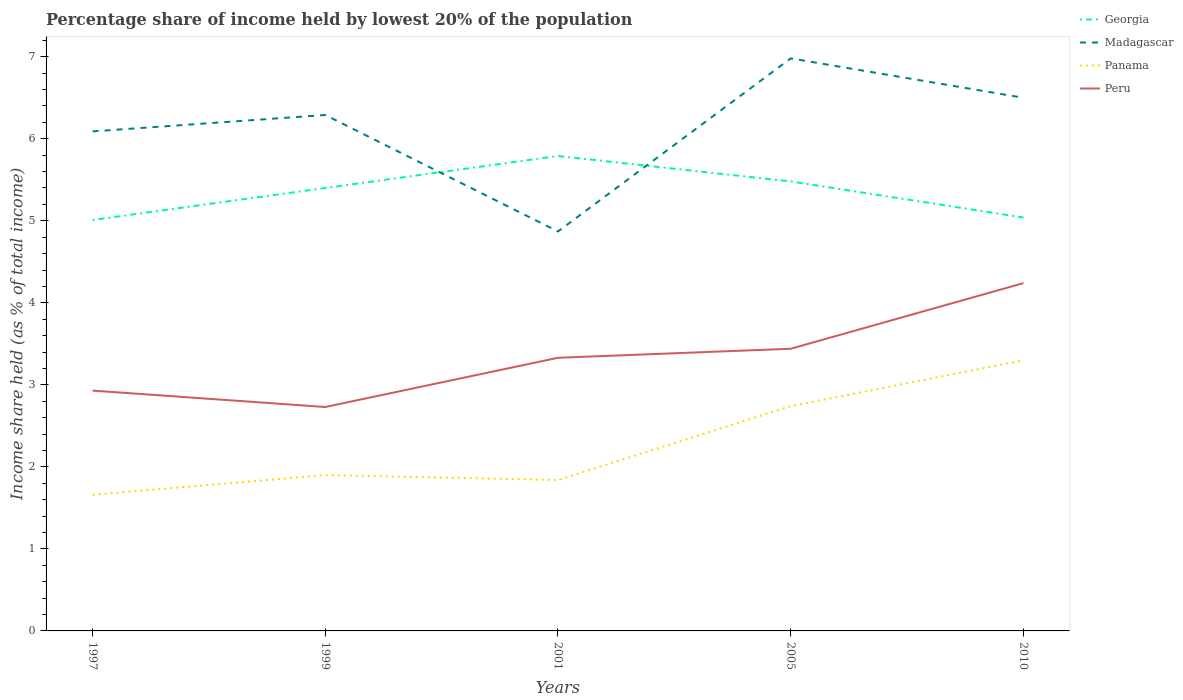Across all years, what is the maximum percentage share of income held by lowest 20% of the population in Panama?
Your response must be concise. 1.66. In which year was the percentage share of income held by lowest 20% of the population in Madagascar maximum?
Your response must be concise. 2001. What is the total percentage share of income held by lowest 20% of the population in Madagascar in the graph?
Provide a succinct answer. -0.2. What is the difference between the highest and the second highest percentage share of income held by lowest 20% of the population in Madagascar?
Ensure brevity in your answer.  2.11. What is the difference between the highest and the lowest percentage share of income held by lowest 20% of the population in Madagascar?
Offer a terse response. 3. How many lines are there?
Your answer should be compact. 4. What is the difference between two consecutive major ticks on the Y-axis?
Your answer should be compact. 1. Are the values on the major ticks of Y-axis written in scientific E-notation?
Your answer should be compact. No. Does the graph contain any zero values?
Ensure brevity in your answer.  No. Does the graph contain grids?
Your answer should be compact. No. How are the legend labels stacked?
Keep it short and to the point. Vertical. What is the title of the graph?
Offer a very short reply. Percentage share of income held by lowest 20% of the population. Does "Pakistan" appear as one of the legend labels in the graph?
Your answer should be compact. No. What is the label or title of the X-axis?
Make the answer very short. Years. What is the label or title of the Y-axis?
Offer a terse response. Income share held (as % of total income). What is the Income share held (as % of total income) in Georgia in 1997?
Make the answer very short. 5.01. What is the Income share held (as % of total income) in Madagascar in 1997?
Offer a terse response. 6.09. What is the Income share held (as % of total income) of Panama in 1997?
Give a very brief answer. 1.66. What is the Income share held (as % of total income) in Peru in 1997?
Your answer should be compact. 2.93. What is the Income share held (as % of total income) in Georgia in 1999?
Ensure brevity in your answer.  5.4. What is the Income share held (as % of total income) of Madagascar in 1999?
Give a very brief answer. 6.29. What is the Income share held (as % of total income) of Peru in 1999?
Keep it short and to the point. 2.73. What is the Income share held (as % of total income) in Georgia in 2001?
Keep it short and to the point. 5.79. What is the Income share held (as % of total income) of Madagascar in 2001?
Provide a short and direct response. 4.87. What is the Income share held (as % of total income) in Panama in 2001?
Your answer should be compact. 1.84. What is the Income share held (as % of total income) of Peru in 2001?
Give a very brief answer. 3.33. What is the Income share held (as % of total income) of Georgia in 2005?
Keep it short and to the point. 5.48. What is the Income share held (as % of total income) in Madagascar in 2005?
Your answer should be very brief. 6.98. What is the Income share held (as % of total income) in Panama in 2005?
Ensure brevity in your answer.  2.74. What is the Income share held (as % of total income) of Peru in 2005?
Give a very brief answer. 3.44. What is the Income share held (as % of total income) in Georgia in 2010?
Offer a very short reply. 5.04. What is the Income share held (as % of total income) of Madagascar in 2010?
Make the answer very short. 6.5. What is the Income share held (as % of total income) in Panama in 2010?
Offer a very short reply. 3.3. What is the Income share held (as % of total income) of Peru in 2010?
Offer a very short reply. 4.24. Across all years, what is the maximum Income share held (as % of total income) of Georgia?
Keep it short and to the point. 5.79. Across all years, what is the maximum Income share held (as % of total income) of Madagascar?
Offer a very short reply. 6.98. Across all years, what is the maximum Income share held (as % of total income) of Panama?
Keep it short and to the point. 3.3. Across all years, what is the maximum Income share held (as % of total income) in Peru?
Provide a succinct answer. 4.24. Across all years, what is the minimum Income share held (as % of total income) of Georgia?
Give a very brief answer. 5.01. Across all years, what is the minimum Income share held (as % of total income) in Madagascar?
Provide a succinct answer. 4.87. Across all years, what is the minimum Income share held (as % of total income) of Panama?
Provide a succinct answer. 1.66. Across all years, what is the minimum Income share held (as % of total income) of Peru?
Provide a short and direct response. 2.73. What is the total Income share held (as % of total income) in Georgia in the graph?
Offer a terse response. 26.72. What is the total Income share held (as % of total income) of Madagascar in the graph?
Ensure brevity in your answer.  30.73. What is the total Income share held (as % of total income) in Panama in the graph?
Keep it short and to the point. 11.44. What is the total Income share held (as % of total income) in Peru in the graph?
Ensure brevity in your answer.  16.67. What is the difference between the Income share held (as % of total income) in Georgia in 1997 and that in 1999?
Offer a terse response. -0.39. What is the difference between the Income share held (as % of total income) of Madagascar in 1997 and that in 1999?
Your response must be concise. -0.2. What is the difference between the Income share held (as % of total income) in Panama in 1997 and that in 1999?
Keep it short and to the point. -0.24. What is the difference between the Income share held (as % of total income) of Peru in 1997 and that in 1999?
Provide a short and direct response. 0.2. What is the difference between the Income share held (as % of total income) in Georgia in 1997 and that in 2001?
Keep it short and to the point. -0.78. What is the difference between the Income share held (as % of total income) in Madagascar in 1997 and that in 2001?
Offer a very short reply. 1.22. What is the difference between the Income share held (as % of total income) in Panama in 1997 and that in 2001?
Offer a very short reply. -0.18. What is the difference between the Income share held (as % of total income) of Peru in 1997 and that in 2001?
Offer a terse response. -0.4. What is the difference between the Income share held (as % of total income) of Georgia in 1997 and that in 2005?
Give a very brief answer. -0.47. What is the difference between the Income share held (as % of total income) of Madagascar in 1997 and that in 2005?
Offer a terse response. -0.89. What is the difference between the Income share held (as % of total income) in Panama in 1997 and that in 2005?
Provide a short and direct response. -1.08. What is the difference between the Income share held (as % of total income) in Peru in 1997 and that in 2005?
Provide a succinct answer. -0.51. What is the difference between the Income share held (as % of total income) in Georgia in 1997 and that in 2010?
Provide a succinct answer. -0.03. What is the difference between the Income share held (as % of total income) of Madagascar in 1997 and that in 2010?
Offer a terse response. -0.41. What is the difference between the Income share held (as % of total income) of Panama in 1997 and that in 2010?
Your answer should be very brief. -1.64. What is the difference between the Income share held (as % of total income) in Peru in 1997 and that in 2010?
Ensure brevity in your answer.  -1.31. What is the difference between the Income share held (as % of total income) in Georgia in 1999 and that in 2001?
Provide a short and direct response. -0.39. What is the difference between the Income share held (as % of total income) of Madagascar in 1999 and that in 2001?
Make the answer very short. 1.42. What is the difference between the Income share held (as % of total income) of Panama in 1999 and that in 2001?
Your answer should be very brief. 0.06. What is the difference between the Income share held (as % of total income) in Peru in 1999 and that in 2001?
Offer a terse response. -0.6. What is the difference between the Income share held (as % of total income) in Georgia in 1999 and that in 2005?
Ensure brevity in your answer.  -0.08. What is the difference between the Income share held (as % of total income) in Madagascar in 1999 and that in 2005?
Your answer should be very brief. -0.69. What is the difference between the Income share held (as % of total income) of Panama in 1999 and that in 2005?
Keep it short and to the point. -0.84. What is the difference between the Income share held (as % of total income) in Peru in 1999 and that in 2005?
Ensure brevity in your answer.  -0.71. What is the difference between the Income share held (as % of total income) of Georgia in 1999 and that in 2010?
Provide a succinct answer. 0.36. What is the difference between the Income share held (as % of total income) in Madagascar in 1999 and that in 2010?
Ensure brevity in your answer.  -0.21. What is the difference between the Income share held (as % of total income) in Panama in 1999 and that in 2010?
Offer a terse response. -1.4. What is the difference between the Income share held (as % of total income) of Peru in 1999 and that in 2010?
Provide a short and direct response. -1.51. What is the difference between the Income share held (as % of total income) of Georgia in 2001 and that in 2005?
Offer a terse response. 0.31. What is the difference between the Income share held (as % of total income) in Madagascar in 2001 and that in 2005?
Provide a succinct answer. -2.11. What is the difference between the Income share held (as % of total income) of Panama in 2001 and that in 2005?
Offer a very short reply. -0.9. What is the difference between the Income share held (as % of total income) in Peru in 2001 and that in 2005?
Offer a terse response. -0.11. What is the difference between the Income share held (as % of total income) of Georgia in 2001 and that in 2010?
Keep it short and to the point. 0.75. What is the difference between the Income share held (as % of total income) in Madagascar in 2001 and that in 2010?
Keep it short and to the point. -1.63. What is the difference between the Income share held (as % of total income) in Panama in 2001 and that in 2010?
Provide a short and direct response. -1.46. What is the difference between the Income share held (as % of total income) of Peru in 2001 and that in 2010?
Provide a short and direct response. -0.91. What is the difference between the Income share held (as % of total income) of Georgia in 2005 and that in 2010?
Offer a very short reply. 0.44. What is the difference between the Income share held (as % of total income) of Madagascar in 2005 and that in 2010?
Make the answer very short. 0.48. What is the difference between the Income share held (as % of total income) of Panama in 2005 and that in 2010?
Keep it short and to the point. -0.56. What is the difference between the Income share held (as % of total income) in Georgia in 1997 and the Income share held (as % of total income) in Madagascar in 1999?
Make the answer very short. -1.28. What is the difference between the Income share held (as % of total income) in Georgia in 1997 and the Income share held (as % of total income) in Panama in 1999?
Make the answer very short. 3.11. What is the difference between the Income share held (as % of total income) of Georgia in 1997 and the Income share held (as % of total income) of Peru in 1999?
Your answer should be very brief. 2.28. What is the difference between the Income share held (as % of total income) in Madagascar in 1997 and the Income share held (as % of total income) in Panama in 1999?
Keep it short and to the point. 4.19. What is the difference between the Income share held (as % of total income) of Madagascar in 1997 and the Income share held (as % of total income) of Peru in 1999?
Give a very brief answer. 3.36. What is the difference between the Income share held (as % of total income) of Panama in 1997 and the Income share held (as % of total income) of Peru in 1999?
Your answer should be very brief. -1.07. What is the difference between the Income share held (as % of total income) of Georgia in 1997 and the Income share held (as % of total income) of Madagascar in 2001?
Keep it short and to the point. 0.14. What is the difference between the Income share held (as % of total income) of Georgia in 1997 and the Income share held (as % of total income) of Panama in 2001?
Provide a succinct answer. 3.17. What is the difference between the Income share held (as % of total income) of Georgia in 1997 and the Income share held (as % of total income) of Peru in 2001?
Your answer should be compact. 1.68. What is the difference between the Income share held (as % of total income) of Madagascar in 1997 and the Income share held (as % of total income) of Panama in 2001?
Ensure brevity in your answer.  4.25. What is the difference between the Income share held (as % of total income) of Madagascar in 1997 and the Income share held (as % of total income) of Peru in 2001?
Your response must be concise. 2.76. What is the difference between the Income share held (as % of total income) in Panama in 1997 and the Income share held (as % of total income) in Peru in 2001?
Give a very brief answer. -1.67. What is the difference between the Income share held (as % of total income) in Georgia in 1997 and the Income share held (as % of total income) in Madagascar in 2005?
Keep it short and to the point. -1.97. What is the difference between the Income share held (as % of total income) in Georgia in 1997 and the Income share held (as % of total income) in Panama in 2005?
Your answer should be very brief. 2.27. What is the difference between the Income share held (as % of total income) of Georgia in 1997 and the Income share held (as % of total income) of Peru in 2005?
Your answer should be very brief. 1.57. What is the difference between the Income share held (as % of total income) in Madagascar in 1997 and the Income share held (as % of total income) in Panama in 2005?
Your response must be concise. 3.35. What is the difference between the Income share held (as % of total income) of Madagascar in 1997 and the Income share held (as % of total income) of Peru in 2005?
Your response must be concise. 2.65. What is the difference between the Income share held (as % of total income) in Panama in 1997 and the Income share held (as % of total income) in Peru in 2005?
Give a very brief answer. -1.78. What is the difference between the Income share held (as % of total income) of Georgia in 1997 and the Income share held (as % of total income) of Madagascar in 2010?
Your answer should be compact. -1.49. What is the difference between the Income share held (as % of total income) in Georgia in 1997 and the Income share held (as % of total income) in Panama in 2010?
Offer a very short reply. 1.71. What is the difference between the Income share held (as % of total income) of Georgia in 1997 and the Income share held (as % of total income) of Peru in 2010?
Ensure brevity in your answer.  0.77. What is the difference between the Income share held (as % of total income) in Madagascar in 1997 and the Income share held (as % of total income) in Panama in 2010?
Offer a terse response. 2.79. What is the difference between the Income share held (as % of total income) of Madagascar in 1997 and the Income share held (as % of total income) of Peru in 2010?
Offer a terse response. 1.85. What is the difference between the Income share held (as % of total income) in Panama in 1997 and the Income share held (as % of total income) in Peru in 2010?
Your answer should be compact. -2.58. What is the difference between the Income share held (as % of total income) of Georgia in 1999 and the Income share held (as % of total income) of Madagascar in 2001?
Provide a succinct answer. 0.53. What is the difference between the Income share held (as % of total income) of Georgia in 1999 and the Income share held (as % of total income) of Panama in 2001?
Ensure brevity in your answer.  3.56. What is the difference between the Income share held (as % of total income) of Georgia in 1999 and the Income share held (as % of total income) of Peru in 2001?
Provide a succinct answer. 2.07. What is the difference between the Income share held (as % of total income) of Madagascar in 1999 and the Income share held (as % of total income) of Panama in 2001?
Give a very brief answer. 4.45. What is the difference between the Income share held (as % of total income) of Madagascar in 1999 and the Income share held (as % of total income) of Peru in 2001?
Your answer should be very brief. 2.96. What is the difference between the Income share held (as % of total income) in Panama in 1999 and the Income share held (as % of total income) in Peru in 2001?
Ensure brevity in your answer.  -1.43. What is the difference between the Income share held (as % of total income) of Georgia in 1999 and the Income share held (as % of total income) of Madagascar in 2005?
Make the answer very short. -1.58. What is the difference between the Income share held (as % of total income) of Georgia in 1999 and the Income share held (as % of total income) of Panama in 2005?
Provide a succinct answer. 2.66. What is the difference between the Income share held (as % of total income) in Georgia in 1999 and the Income share held (as % of total income) in Peru in 2005?
Offer a terse response. 1.96. What is the difference between the Income share held (as % of total income) in Madagascar in 1999 and the Income share held (as % of total income) in Panama in 2005?
Give a very brief answer. 3.55. What is the difference between the Income share held (as % of total income) in Madagascar in 1999 and the Income share held (as % of total income) in Peru in 2005?
Provide a succinct answer. 2.85. What is the difference between the Income share held (as % of total income) in Panama in 1999 and the Income share held (as % of total income) in Peru in 2005?
Your answer should be very brief. -1.54. What is the difference between the Income share held (as % of total income) of Georgia in 1999 and the Income share held (as % of total income) of Madagascar in 2010?
Offer a terse response. -1.1. What is the difference between the Income share held (as % of total income) of Georgia in 1999 and the Income share held (as % of total income) of Panama in 2010?
Give a very brief answer. 2.1. What is the difference between the Income share held (as % of total income) of Georgia in 1999 and the Income share held (as % of total income) of Peru in 2010?
Provide a succinct answer. 1.16. What is the difference between the Income share held (as % of total income) of Madagascar in 1999 and the Income share held (as % of total income) of Panama in 2010?
Your answer should be compact. 2.99. What is the difference between the Income share held (as % of total income) in Madagascar in 1999 and the Income share held (as % of total income) in Peru in 2010?
Ensure brevity in your answer.  2.05. What is the difference between the Income share held (as % of total income) of Panama in 1999 and the Income share held (as % of total income) of Peru in 2010?
Your answer should be compact. -2.34. What is the difference between the Income share held (as % of total income) of Georgia in 2001 and the Income share held (as % of total income) of Madagascar in 2005?
Provide a succinct answer. -1.19. What is the difference between the Income share held (as % of total income) of Georgia in 2001 and the Income share held (as % of total income) of Panama in 2005?
Keep it short and to the point. 3.05. What is the difference between the Income share held (as % of total income) of Georgia in 2001 and the Income share held (as % of total income) of Peru in 2005?
Ensure brevity in your answer.  2.35. What is the difference between the Income share held (as % of total income) of Madagascar in 2001 and the Income share held (as % of total income) of Panama in 2005?
Provide a succinct answer. 2.13. What is the difference between the Income share held (as % of total income) of Madagascar in 2001 and the Income share held (as % of total income) of Peru in 2005?
Offer a terse response. 1.43. What is the difference between the Income share held (as % of total income) in Panama in 2001 and the Income share held (as % of total income) in Peru in 2005?
Provide a short and direct response. -1.6. What is the difference between the Income share held (as % of total income) of Georgia in 2001 and the Income share held (as % of total income) of Madagascar in 2010?
Your answer should be very brief. -0.71. What is the difference between the Income share held (as % of total income) of Georgia in 2001 and the Income share held (as % of total income) of Panama in 2010?
Your answer should be very brief. 2.49. What is the difference between the Income share held (as % of total income) of Georgia in 2001 and the Income share held (as % of total income) of Peru in 2010?
Offer a very short reply. 1.55. What is the difference between the Income share held (as % of total income) in Madagascar in 2001 and the Income share held (as % of total income) in Panama in 2010?
Offer a terse response. 1.57. What is the difference between the Income share held (as % of total income) of Madagascar in 2001 and the Income share held (as % of total income) of Peru in 2010?
Your answer should be very brief. 0.63. What is the difference between the Income share held (as % of total income) of Georgia in 2005 and the Income share held (as % of total income) of Madagascar in 2010?
Your response must be concise. -1.02. What is the difference between the Income share held (as % of total income) in Georgia in 2005 and the Income share held (as % of total income) in Panama in 2010?
Offer a terse response. 2.18. What is the difference between the Income share held (as % of total income) in Georgia in 2005 and the Income share held (as % of total income) in Peru in 2010?
Offer a very short reply. 1.24. What is the difference between the Income share held (as % of total income) in Madagascar in 2005 and the Income share held (as % of total income) in Panama in 2010?
Ensure brevity in your answer.  3.68. What is the difference between the Income share held (as % of total income) in Madagascar in 2005 and the Income share held (as % of total income) in Peru in 2010?
Make the answer very short. 2.74. What is the difference between the Income share held (as % of total income) of Panama in 2005 and the Income share held (as % of total income) of Peru in 2010?
Provide a short and direct response. -1.5. What is the average Income share held (as % of total income) in Georgia per year?
Keep it short and to the point. 5.34. What is the average Income share held (as % of total income) of Madagascar per year?
Your response must be concise. 6.15. What is the average Income share held (as % of total income) of Panama per year?
Ensure brevity in your answer.  2.29. What is the average Income share held (as % of total income) in Peru per year?
Your answer should be very brief. 3.33. In the year 1997, what is the difference between the Income share held (as % of total income) in Georgia and Income share held (as % of total income) in Madagascar?
Your answer should be very brief. -1.08. In the year 1997, what is the difference between the Income share held (as % of total income) in Georgia and Income share held (as % of total income) in Panama?
Keep it short and to the point. 3.35. In the year 1997, what is the difference between the Income share held (as % of total income) in Georgia and Income share held (as % of total income) in Peru?
Ensure brevity in your answer.  2.08. In the year 1997, what is the difference between the Income share held (as % of total income) in Madagascar and Income share held (as % of total income) in Panama?
Provide a succinct answer. 4.43. In the year 1997, what is the difference between the Income share held (as % of total income) in Madagascar and Income share held (as % of total income) in Peru?
Your answer should be compact. 3.16. In the year 1997, what is the difference between the Income share held (as % of total income) in Panama and Income share held (as % of total income) in Peru?
Offer a very short reply. -1.27. In the year 1999, what is the difference between the Income share held (as % of total income) of Georgia and Income share held (as % of total income) of Madagascar?
Offer a very short reply. -0.89. In the year 1999, what is the difference between the Income share held (as % of total income) of Georgia and Income share held (as % of total income) of Peru?
Your answer should be very brief. 2.67. In the year 1999, what is the difference between the Income share held (as % of total income) in Madagascar and Income share held (as % of total income) in Panama?
Make the answer very short. 4.39. In the year 1999, what is the difference between the Income share held (as % of total income) in Madagascar and Income share held (as % of total income) in Peru?
Provide a short and direct response. 3.56. In the year 1999, what is the difference between the Income share held (as % of total income) in Panama and Income share held (as % of total income) in Peru?
Offer a terse response. -0.83. In the year 2001, what is the difference between the Income share held (as % of total income) in Georgia and Income share held (as % of total income) in Panama?
Make the answer very short. 3.95. In the year 2001, what is the difference between the Income share held (as % of total income) in Georgia and Income share held (as % of total income) in Peru?
Give a very brief answer. 2.46. In the year 2001, what is the difference between the Income share held (as % of total income) in Madagascar and Income share held (as % of total income) in Panama?
Your answer should be compact. 3.03. In the year 2001, what is the difference between the Income share held (as % of total income) in Madagascar and Income share held (as % of total income) in Peru?
Make the answer very short. 1.54. In the year 2001, what is the difference between the Income share held (as % of total income) of Panama and Income share held (as % of total income) of Peru?
Your answer should be very brief. -1.49. In the year 2005, what is the difference between the Income share held (as % of total income) in Georgia and Income share held (as % of total income) in Madagascar?
Provide a short and direct response. -1.5. In the year 2005, what is the difference between the Income share held (as % of total income) in Georgia and Income share held (as % of total income) in Panama?
Offer a very short reply. 2.74. In the year 2005, what is the difference between the Income share held (as % of total income) in Georgia and Income share held (as % of total income) in Peru?
Offer a terse response. 2.04. In the year 2005, what is the difference between the Income share held (as % of total income) of Madagascar and Income share held (as % of total income) of Panama?
Your answer should be compact. 4.24. In the year 2005, what is the difference between the Income share held (as % of total income) in Madagascar and Income share held (as % of total income) in Peru?
Offer a terse response. 3.54. In the year 2005, what is the difference between the Income share held (as % of total income) in Panama and Income share held (as % of total income) in Peru?
Make the answer very short. -0.7. In the year 2010, what is the difference between the Income share held (as % of total income) of Georgia and Income share held (as % of total income) of Madagascar?
Offer a terse response. -1.46. In the year 2010, what is the difference between the Income share held (as % of total income) in Georgia and Income share held (as % of total income) in Panama?
Provide a succinct answer. 1.74. In the year 2010, what is the difference between the Income share held (as % of total income) in Madagascar and Income share held (as % of total income) in Panama?
Offer a terse response. 3.2. In the year 2010, what is the difference between the Income share held (as % of total income) in Madagascar and Income share held (as % of total income) in Peru?
Give a very brief answer. 2.26. In the year 2010, what is the difference between the Income share held (as % of total income) of Panama and Income share held (as % of total income) of Peru?
Provide a succinct answer. -0.94. What is the ratio of the Income share held (as % of total income) of Georgia in 1997 to that in 1999?
Give a very brief answer. 0.93. What is the ratio of the Income share held (as % of total income) of Madagascar in 1997 to that in 1999?
Keep it short and to the point. 0.97. What is the ratio of the Income share held (as % of total income) of Panama in 1997 to that in 1999?
Provide a short and direct response. 0.87. What is the ratio of the Income share held (as % of total income) of Peru in 1997 to that in 1999?
Your response must be concise. 1.07. What is the ratio of the Income share held (as % of total income) in Georgia in 1997 to that in 2001?
Ensure brevity in your answer.  0.87. What is the ratio of the Income share held (as % of total income) in Madagascar in 1997 to that in 2001?
Your answer should be very brief. 1.25. What is the ratio of the Income share held (as % of total income) of Panama in 1997 to that in 2001?
Provide a short and direct response. 0.9. What is the ratio of the Income share held (as % of total income) in Peru in 1997 to that in 2001?
Your response must be concise. 0.88. What is the ratio of the Income share held (as % of total income) in Georgia in 1997 to that in 2005?
Ensure brevity in your answer.  0.91. What is the ratio of the Income share held (as % of total income) in Madagascar in 1997 to that in 2005?
Provide a succinct answer. 0.87. What is the ratio of the Income share held (as % of total income) of Panama in 1997 to that in 2005?
Your answer should be very brief. 0.61. What is the ratio of the Income share held (as % of total income) of Peru in 1997 to that in 2005?
Your answer should be very brief. 0.85. What is the ratio of the Income share held (as % of total income) of Georgia in 1997 to that in 2010?
Provide a short and direct response. 0.99. What is the ratio of the Income share held (as % of total income) in Madagascar in 1997 to that in 2010?
Ensure brevity in your answer.  0.94. What is the ratio of the Income share held (as % of total income) in Panama in 1997 to that in 2010?
Give a very brief answer. 0.5. What is the ratio of the Income share held (as % of total income) of Peru in 1997 to that in 2010?
Make the answer very short. 0.69. What is the ratio of the Income share held (as % of total income) in Georgia in 1999 to that in 2001?
Your answer should be compact. 0.93. What is the ratio of the Income share held (as % of total income) of Madagascar in 1999 to that in 2001?
Your response must be concise. 1.29. What is the ratio of the Income share held (as % of total income) in Panama in 1999 to that in 2001?
Your answer should be compact. 1.03. What is the ratio of the Income share held (as % of total income) of Peru in 1999 to that in 2001?
Provide a short and direct response. 0.82. What is the ratio of the Income share held (as % of total income) of Georgia in 1999 to that in 2005?
Provide a short and direct response. 0.99. What is the ratio of the Income share held (as % of total income) in Madagascar in 1999 to that in 2005?
Provide a succinct answer. 0.9. What is the ratio of the Income share held (as % of total income) in Panama in 1999 to that in 2005?
Your answer should be compact. 0.69. What is the ratio of the Income share held (as % of total income) in Peru in 1999 to that in 2005?
Give a very brief answer. 0.79. What is the ratio of the Income share held (as % of total income) of Georgia in 1999 to that in 2010?
Your answer should be compact. 1.07. What is the ratio of the Income share held (as % of total income) of Panama in 1999 to that in 2010?
Keep it short and to the point. 0.58. What is the ratio of the Income share held (as % of total income) in Peru in 1999 to that in 2010?
Offer a very short reply. 0.64. What is the ratio of the Income share held (as % of total income) in Georgia in 2001 to that in 2005?
Provide a succinct answer. 1.06. What is the ratio of the Income share held (as % of total income) of Madagascar in 2001 to that in 2005?
Your answer should be compact. 0.7. What is the ratio of the Income share held (as % of total income) of Panama in 2001 to that in 2005?
Keep it short and to the point. 0.67. What is the ratio of the Income share held (as % of total income) of Peru in 2001 to that in 2005?
Provide a succinct answer. 0.97. What is the ratio of the Income share held (as % of total income) in Georgia in 2001 to that in 2010?
Keep it short and to the point. 1.15. What is the ratio of the Income share held (as % of total income) in Madagascar in 2001 to that in 2010?
Offer a very short reply. 0.75. What is the ratio of the Income share held (as % of total income) in Panama in 2001 to that in 2010?
Provide a succinct answer. 0.56. What is the ratio of the Income share held (as % of total income) of Peru in 2001 to that in 2010?
Provide a short and direct response. 0.79. What is the ratio of the Income share held (as % of total income) of Georgia in 2005 to that in 2010?
Keep it short and to the point. 1.09. What is the ratio of the Income share held (as % of total income) in Madagascar in 2005 to that in 2010?
Your response must be concise. 1.07. What is the ratio of the Income share held (as % of total income) in Panama in 2005 to that in 2010?
Offer a terse response. 0.83. What is the ratio of the Income share held (as % of total income) of Peru in 2005 to that in 2010?
Offer a terse response. 0.81. What is the difference between the highest and the second highest Income share held (as % of total income) of Georgia?
Your answer should be compact. 0.31. What is the difference between the highest and the second highest Income share held (as % of total income) of Madagascar?
Ensure brevity in your answer.  0.48. What is the difference between the highest and the second highest Income share held (as % of total income) in Panama?
Ensure brevity in your answer.  0.56. What is the difference between the highest and the second highest Income share held (as % of total income) in Peru?
Provide a succinct answer. 0.8. What is the difference between the highest and the lowest Income share held (as % of total income) in Georgia?
Provide a succinct answer. 0.78. What is the difference between the highest and the lowest Income share held (as % of total income) in Madagascar?
Provide a short and direct response. 2.11. What is the difference between the highest and the lowest Income share held (as % of total income) in Panama?
Your answer should be very brief. 1.64. What is the difference between the highest and the lowest Income share held (as % of total income) of Peru?
Keep it short and to the point. 1.51. 